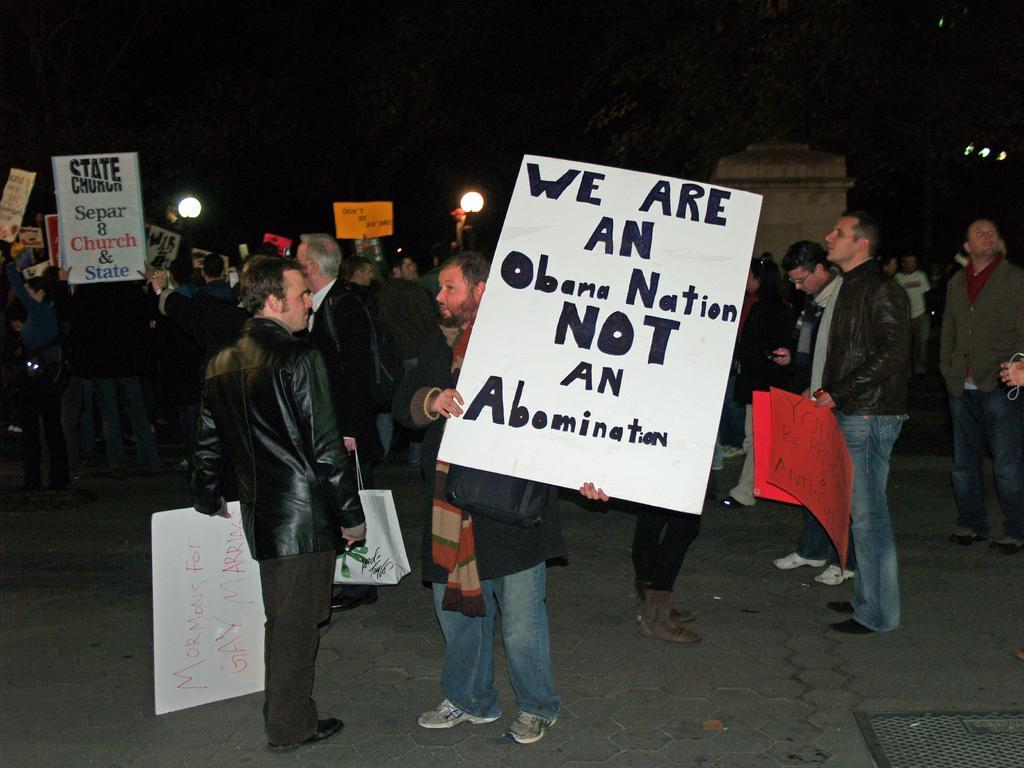Describe this image in one or two sentences. In this image there are few people standing on the ground by holding the placard. In the middle there is a person who is holding the big placard. On the right side there is another person who is standing on the floor by holding the two placards. In the background there is a wall. 